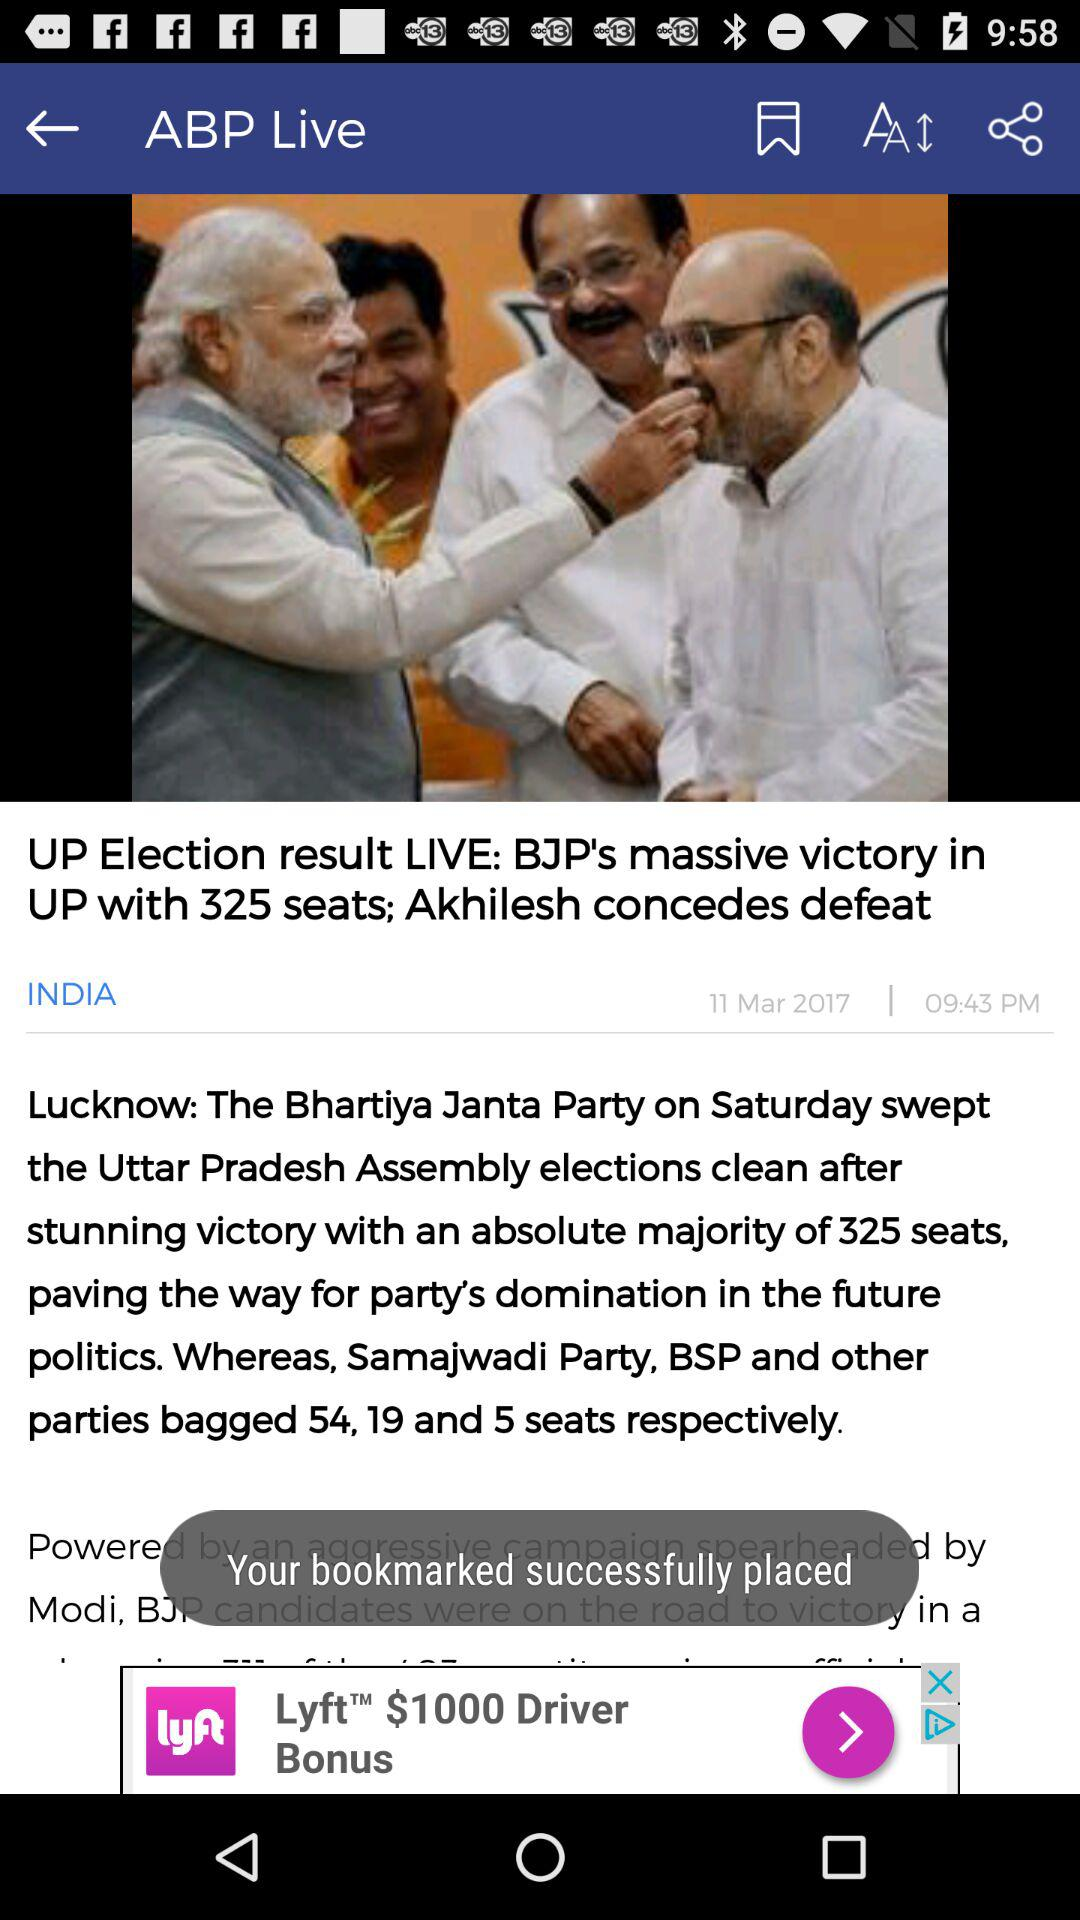When was the article updated? The article was updated on March 11, 2017. 